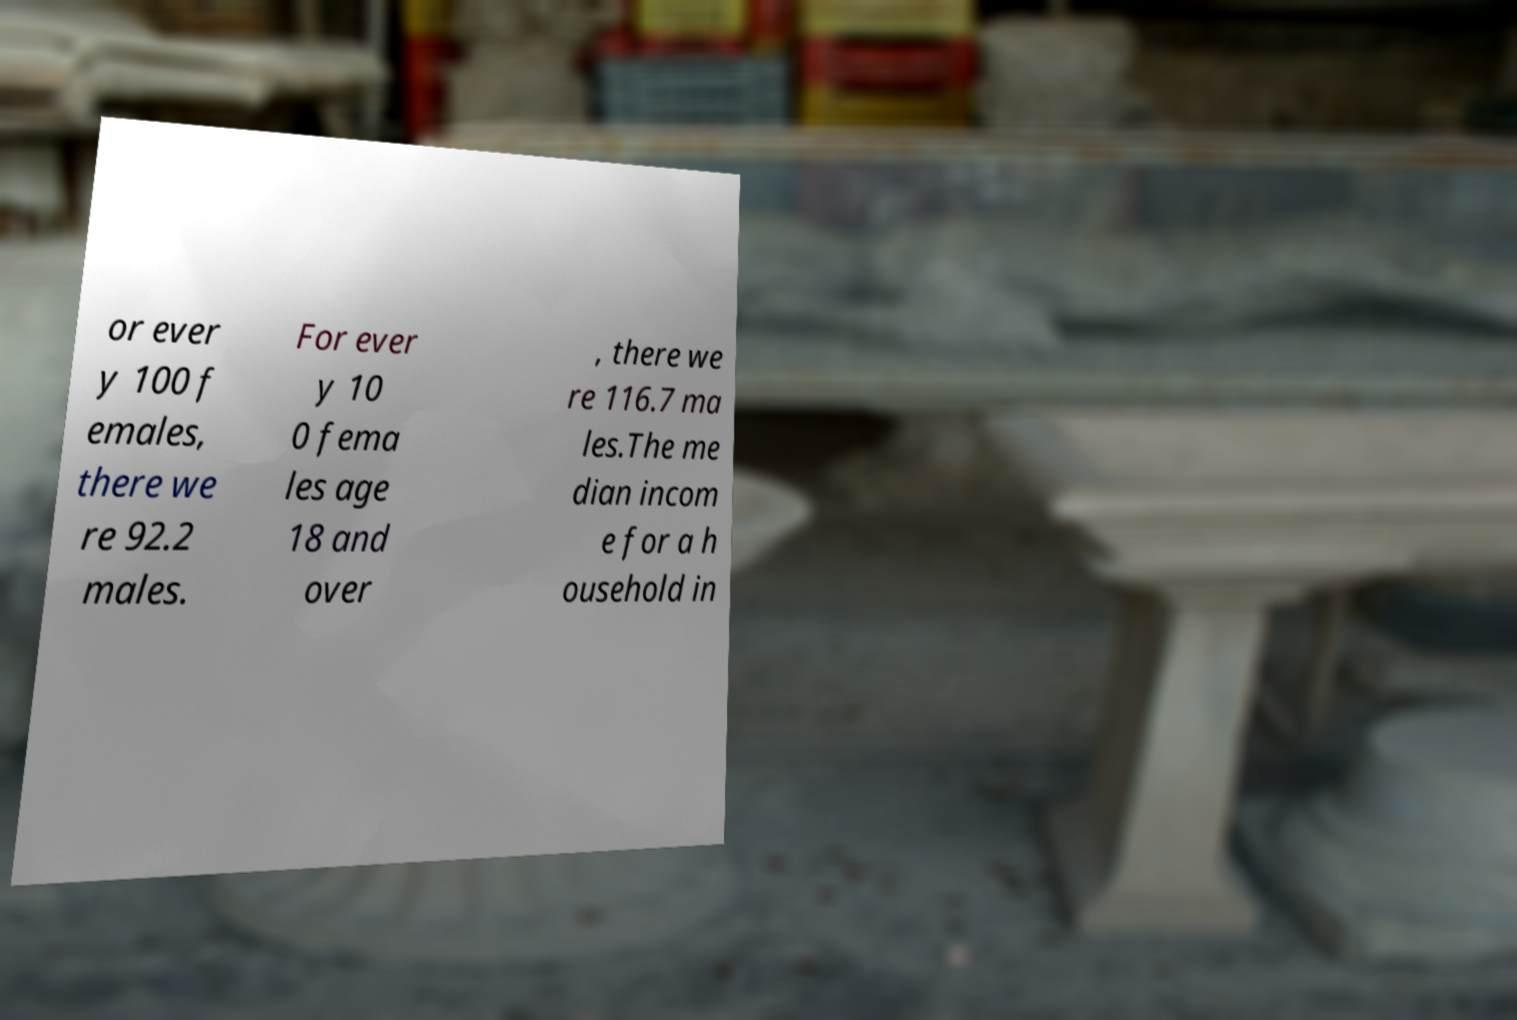What messages or text are displayed in this image? I need them in a readable, typed format. or ever y 100 f emales, there we re 92.2 males. For ever y 10 0 fema les age 18 and over , there we re 116.7 ma les.The me dian incom e for a h ousehold in 